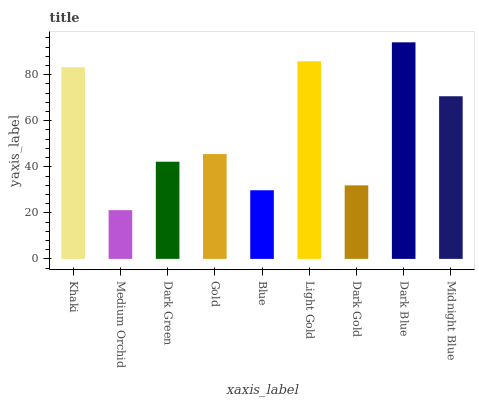Is Medium Orchid the minimum?
Answer yes or no. Yes. Is Dark Blue the maximum?
Answer yes or no. Yes. Is Dark Green the minimum?
Answer yes or no. No. Is Dark Green the maximum?
Answer yes or no. No. Is Dark Green greater than Medium Orchid?
Answer yes or no. Yes. Is Medium Orchid less than Dark Green?
Answer yes or no. Yes. Is Medium Orchid greater than Dark Green?
Answer yes or no. No. Is Dark Green less than Medium Orchid?
Answer yes or no. No. Is Gold the high median?
Answer yes or no. Yes. Is Gold the low median?
Answer yes or no. Yes. Is Light Gold the high median?
Answer yes or no. No. Is Khaki the low median?
Answer yes or no. No. 